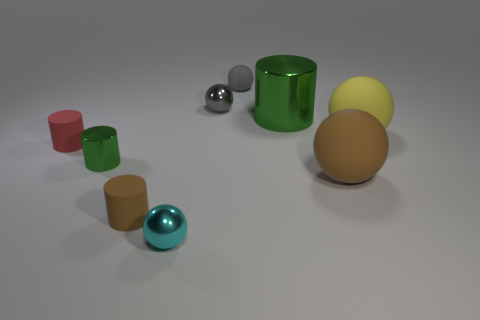How many small brown cylinders are behind the yellow matte thing?
Ensure brevity in your answer.  0. The red matte thing that is the same shape as the small brown matte object is what size?
Your response must be concise. Small. There is a matte thing that is behind the small red thing and right of the large green object; what size is it?
Give a very brief answer. Large. Is the color of the big metallic cylinder the same as the shiny cylinder on the left side of the cyan shiny thing?
Provide a short and direct response. Yes. How many brown things are either matte cylinders or tiny matte cubes?
Provide a short and direct response. 1. What is the shape of the big yellow thing?
Your answer should be very brief. Sphere. How many other objects are the same shape as the gray matte object?
Keep it short and to the point. 4. There is a shiny object that is in front of the brown cylinder; what color is it?
Provide a succinct answer. Cyan. Is the material of the big green cylinder the same as the cyan sphere?
Ensure brevity in your answer.  Yes. How many things are small yellow rubber cubes or shiny balls that are in front of the small brown rubber object?
Your answer should be compact. 1. 